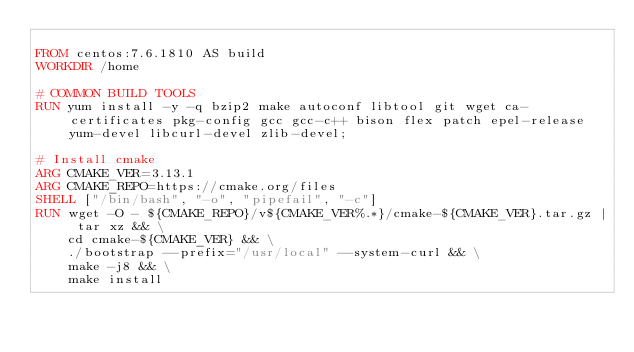<code> <loc_0><loc_0><loc_500><loc_500><_Dockerfile_>
FROM centos:7.6.1810 AS build
WORKDIR /home

# COMMON BUILD TOOLS
RUN yum install -y -q bzip2 make autoconf libtool git wget ca-certificates pkg-config gcc gcc-c++ bison flex patch epel-release yum-devel libcurl-devel zlib-devel;

# Install cmake
ARG CMAKE_VER=3.13.1
ARG CMAKE_REPO=https://cmake.org/files
SHELL ["/bin/bash", "-o", "pipefail", "-c"]
RUN wget -O - ${CMAKE_REPO}/v${CMAKE_VER%.*}/cmake-${CMAKE_VER}.tar.gz | tar xz && \
    cd cmake-${CMAKE_VER} && \
    ./bootstrap --prefix="/usr/local" --system-curl && \
    make -j8 && \
    make install
</code> 